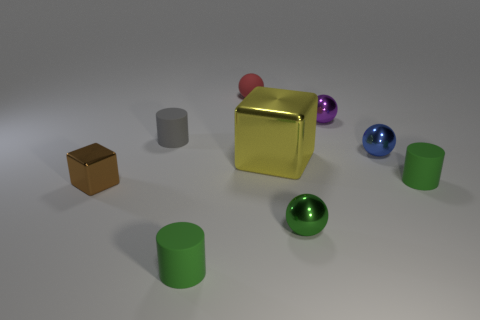There is a thing that is on the left side of the tiny green metallic sphere and in front of the small block; what is its shape? The object you're referring to, located to the left of the tiny green metallic sphere and in front of the small block, has a shape that is cylindrical, a 3D shape with circular ends and straight parallel sides. 